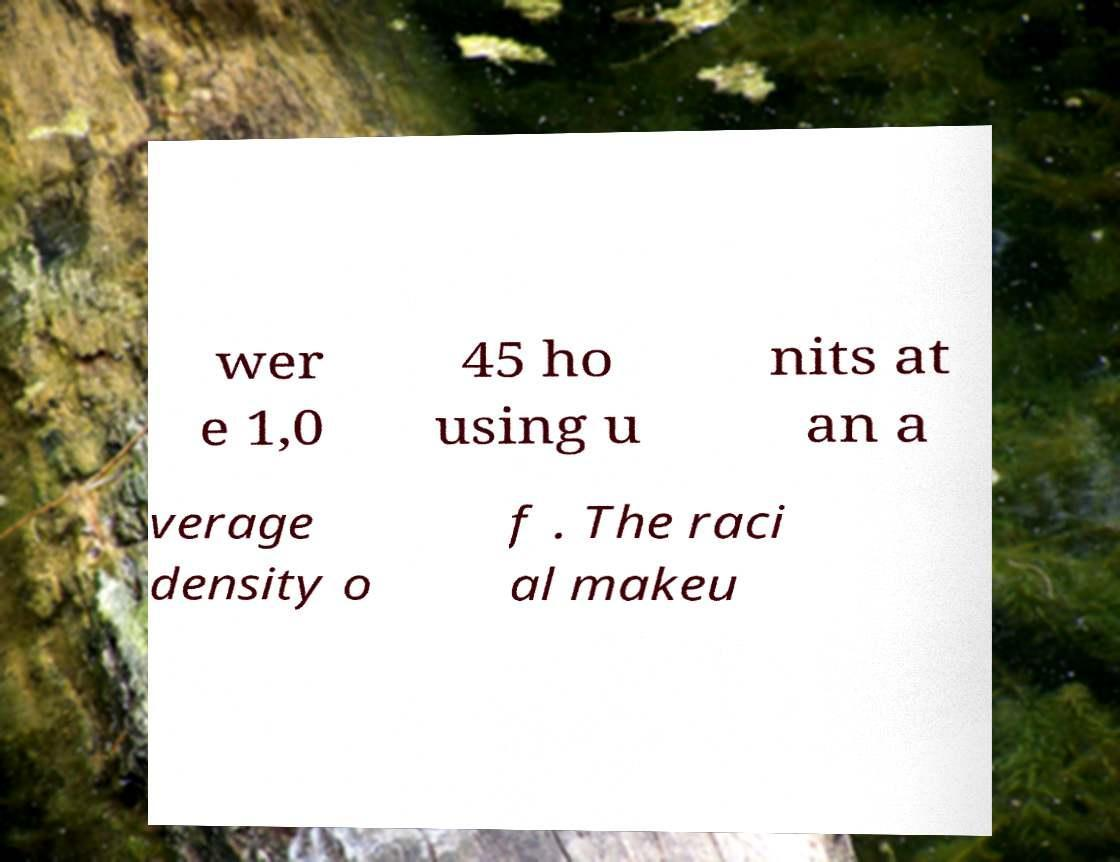Please identify and transcribe the text found in this image. wer e 1,0 45 ho using u nits at an a verage density o f . The raci al makeu 